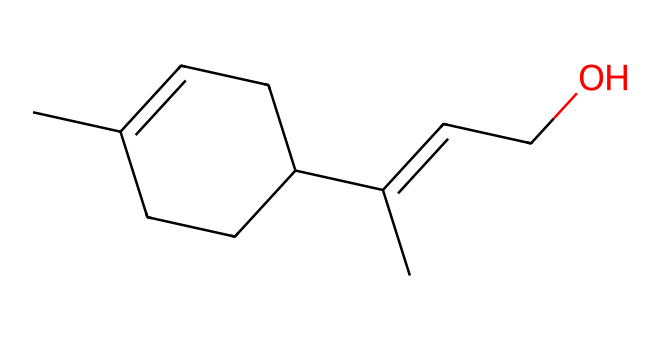How many carbon atoms are in linalool? By examining the SMILES representation, we count the number of 'C' symbols. There are 10 carbon atoms present in the structure, indicating it has a carbon backbone typical of terpenes.
Answer: 10 What type of functional group is present in linalool? The SMILES shows an -OH (hydroxyl) group indicated by 'C(CO)', which identifies it as an alcohol. Since this compound has a hydroxyl functional group, it signifies its classification within the alcohols.
Answer: alcohol How many double bonds are in the structure of linalool? By analyzing the SMILES, we spot double bonds indicated by the '=' signs. There are two double bonds, which are crucial for determining the compound's reactivity and characteristics.
Answer: 2 What primary characteristic defines linalool as a terpene? Linalool's structure contains a specific arrangement of carbon atoms in a cyclic and acyclic arrangement with multiple double bonds and functional groups, typical of terpenes, classifying it under this category.
Answer: aromatic What is the molecular formula of linalool? To derive the molecular formula, we tally the number of each type of atom seen in the structure: 10 carbon, 18 hydrogen, and 1 oxygen atom, resulting in the formula C10H18O for linalool.
Answer: C10H18O How does linalool's structure contribute to its fragrant aroma? The unique arrangement of carbon and functional groups in linalool allows for specific interactions with olfactory receptors. The presence of the double bonds and the alcohol functional group enhance its volatility and aromatic properties.
Answer: enhances aroma What does the presence of the hydroxyl group indicate about linalool's solubility? The presence of the hydroxyl (-OH) functional group typically increases solubility in water due to hydrogen bonding. Linalool's structure should promote its solubility in polar solvents.
Answer: soluble in water 